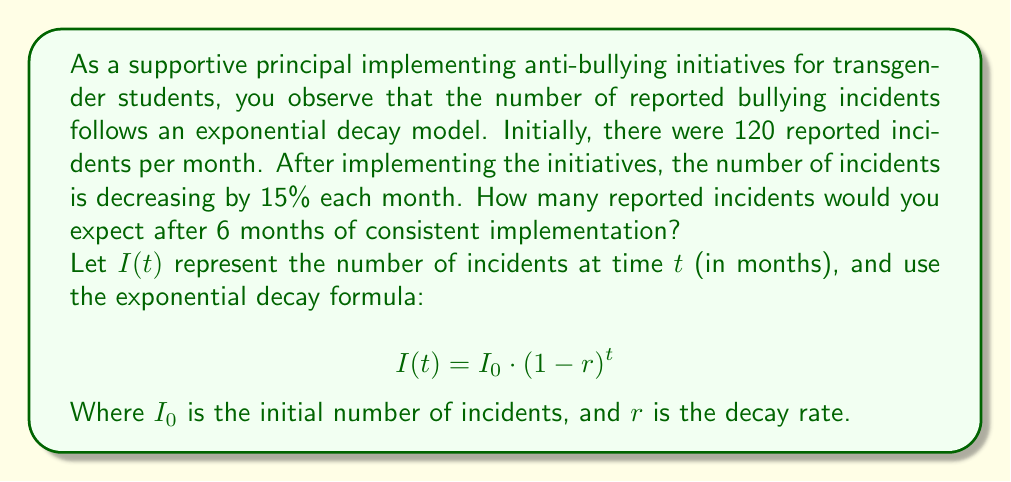Solve this math problem. Let's solve this problem step-by-step:

1) We're given:
   - Initial number of incidents, $I_0 = 120$
   - Decay rate, $r = 15\% = 0.15$
   - Time, $t = 6$ months

2) We'll use the exponential decay formula:
   $$I(t) = I_0 \cdot (1-r)^t$$

3) Substituting our values:
   $$I(6) = 120 \cdot (1-0.15)^6$$

4) Simplify inside the parentheses:
   $$I(6) = 120 \cdot (0.85)^6$$

5) Calculate $(0.85)^6$:
   $(0.85)^6 \approx 0.3771$

6) Multiply:
   $$I(6) = 120 \cdot 0.3771 \approx 45.252$$

7) Since we're dealing with incidents, we round to the nearest whole number:
   $$I(6) \approx 45$$
Answer: 45 incidents 